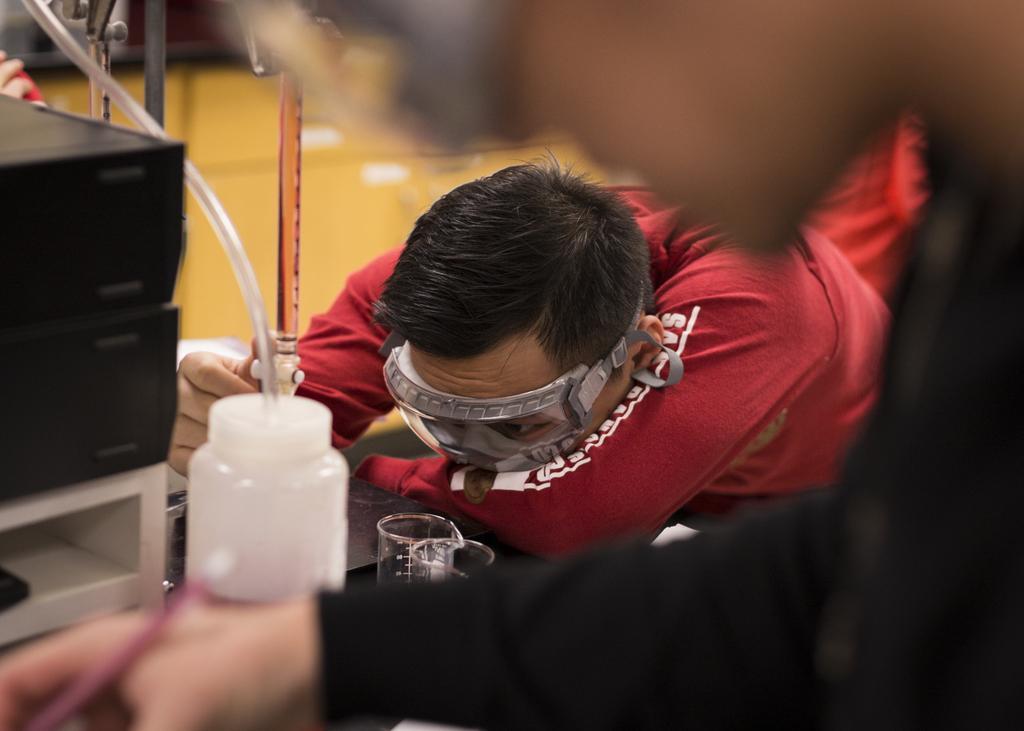Please provide a concise description of this image. In this picture we can see few people, in the middle of the image we can see a man, he wore spectacles, in front of him we can find few glasses and few chemical lab things on the table. 